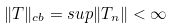<formula> <loc_0><loc_0><loc_500><loc_500>\| T \| _ { c b } = s u p \| T _ { n } \| < \infty</formula> 